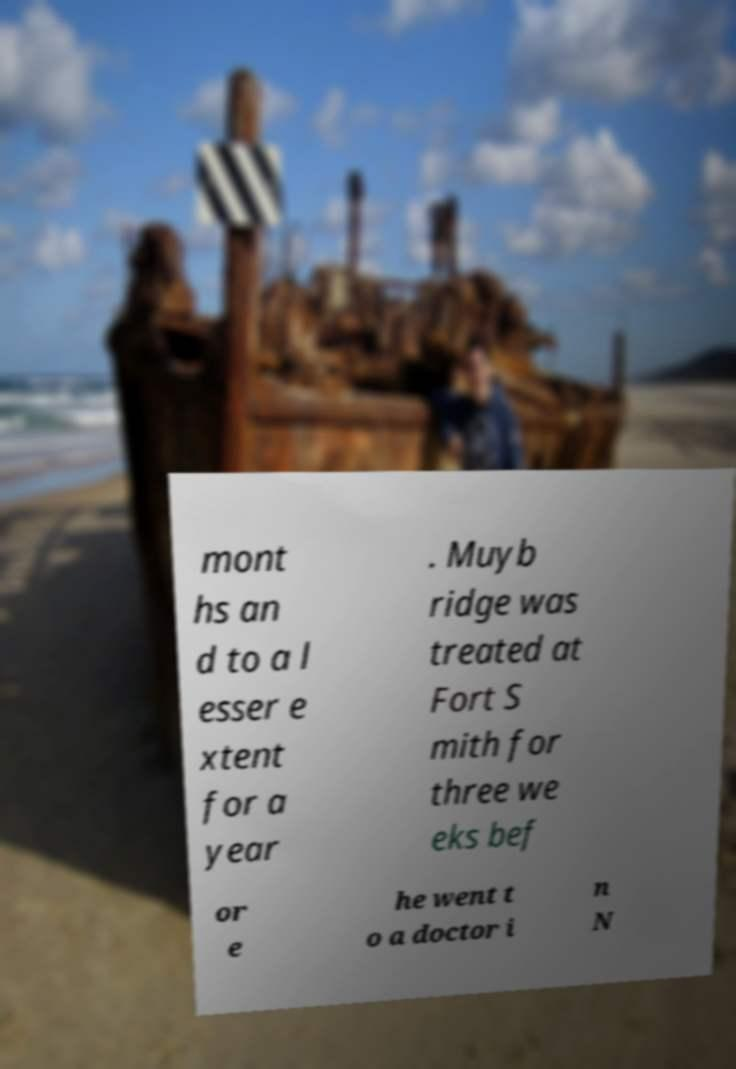Please identify and transcribe the text found in this image. mont hs an d to a l esser e xtent for a year . Muyb ridge was treated at Fort S mith for three we eks bef or e he went t o a doctor i n N 